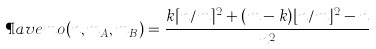Convert formula to latex. <formula><loc_0><loc_0><loc_500><loc_500>\P a v e m o ( n , m _ { A } , m _ { B } ) = \frac { k \lceil n / m \rceil ^ { 2 } + ( m - k ) \lfloor n / m \rfloor ^ { 2 } - n } { n ^ { 2 } }</formula> 